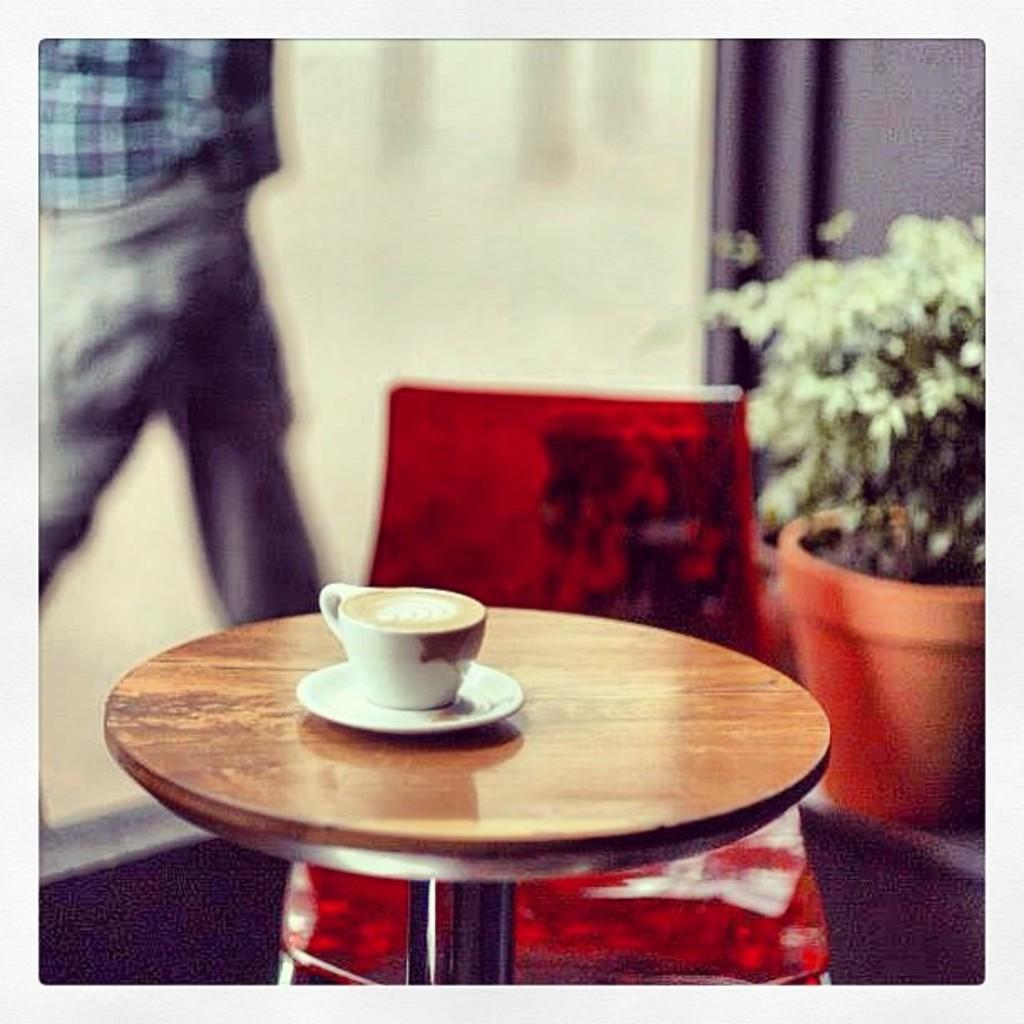Can you describe this image briefly? In this image there is a table and chair, a cup of coffee is placed on the table and at the right side of the image there is a plant and at the left side of the image there is a man walking through the corridor and at the middle of the image there is a white and blue color sheet 